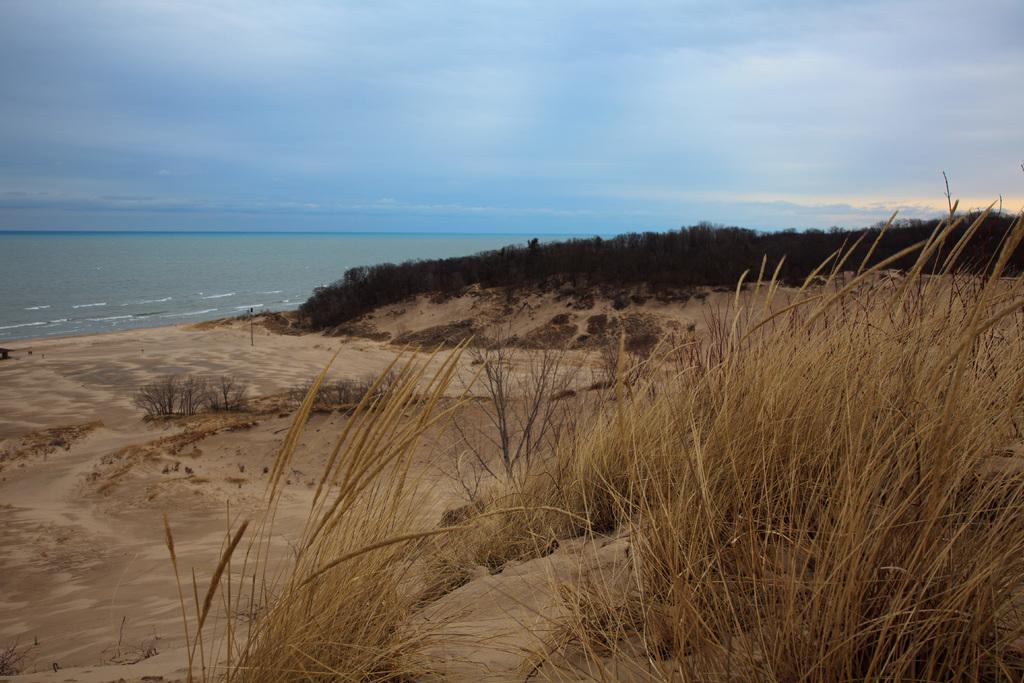What type of environment is depicted in the image? The image shows an open area with trees, plants, and grass. What natural features can be seen in the background of the image? The ocean is visible in the background of the image. What is visible at the top of the image? The sky is visible at the top of the image, and clouds are present in the sky. Where is the market located in the image? There is no market present in the image. How tall are the giants in the image? There are no giants present in the image. 